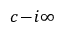<formula> <loc_0><loc_0><loc_500><loc_500>c \, - \, i \infty</formula> 